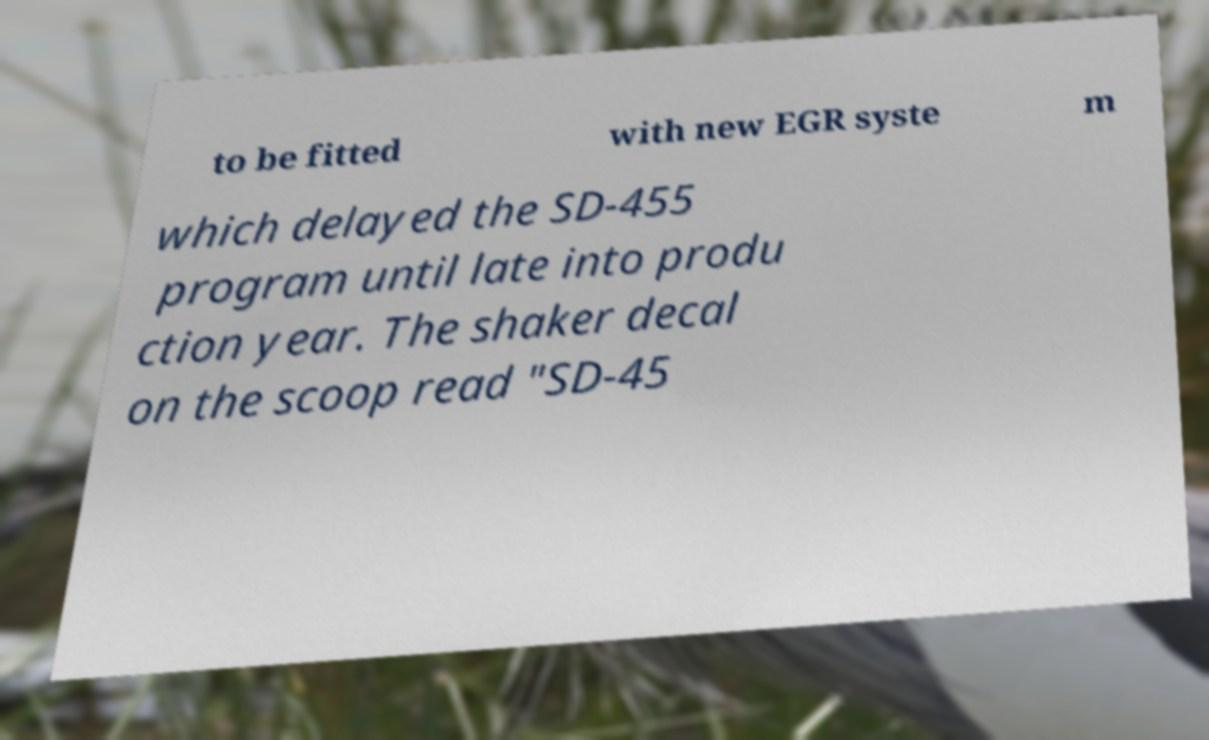There's text embedded in this image that I need extracted. Can you transcribe it verbatim? to be fitted with new EGR syste m which delayed the SD-455 program until late into produ ction year. The shaker decal on the scoop read "SD-45 